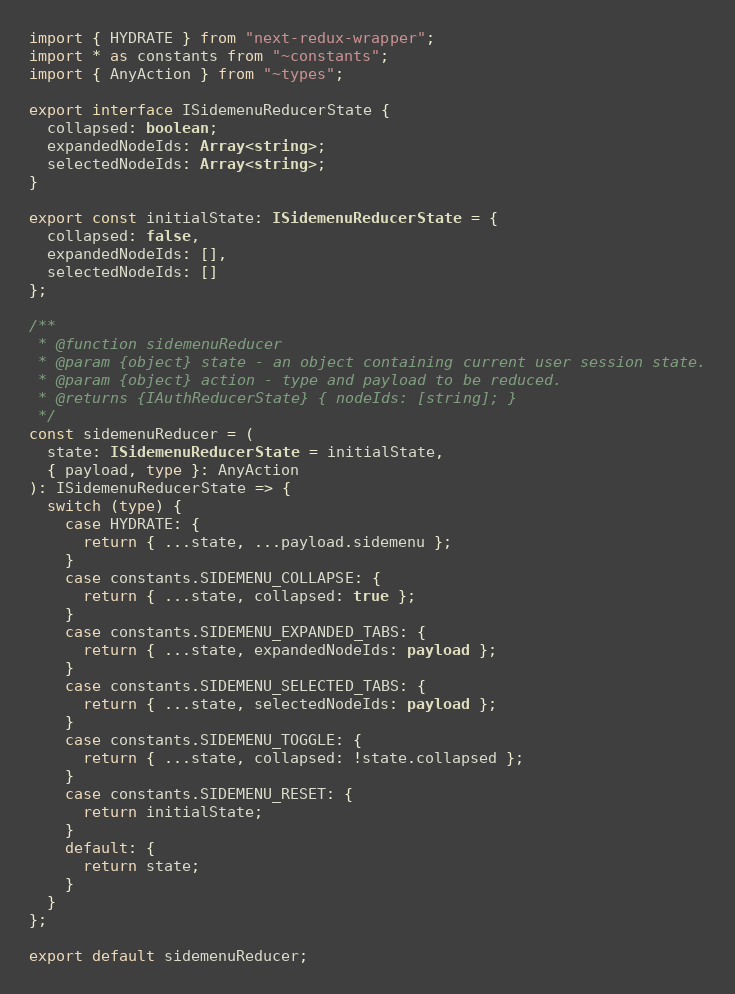Convert code to text. <code><loc_0><loc_0><loc_500><loc_500><_TypeScript_>import { HYDRATE } from "next-redux-wrapper";
import * as constants from "~constants";
import { AnyAction } from "~types";

export interface ISidemenuReducerState {
  collapsed: boolean;
  expandedNodeIds: Array<string>;
  selectedNodeIds: Array<string>;
}

export const initialState: ISidemenuReducerState = {
  collapsed: false,
  expandedNodeIds: [],
  selectedNodeIds: []
};

/**
 * @function sidemenuReducer
 * @param {object} state - an object containing current user session state.
 * @param {object} action - type and payload to be reduced.
 * @returns {IAuthReducerState} { nodeIds: [string]; }
 */
const sidemenuReducer = (
  state: ISidemenuReducerState = initialState,
  { payload, type }: AnyAction
): ISidemenuReducerState => {
  switch (type) {
    case HYDRATE: {
      return { ...state, ...payload.sidemenu };
    }
    case constants.SIDEMENU_COLLAPSE: {
      return { ...state, collapsed: true };
    }
    case constants.SIDEMENU_EXPANDED_TABS: {
      return { ...state, expandedNodeIds: payload };
    }
    case constants.SIDEMENU_SELECTED_TABS: {
      return { ...state, selectedNodeIds: payload };
    }
    case constants.SIDEMENU_TOGGLE: {
      return { ...state, collapsed: !state.collapsed };
    }
    case constants.SIDEMENU_RESET: {
      return initialState;
    }
    default: {
      return state;
    }
  }
};

export default sidemenuReducer;
</code> 